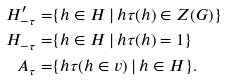Convert formula to latex. <formula><loc_0><loc_0><loc_500><loc_500>H ^ { \prime } _ { - \tau } = & \{ h \in H \, | \, h \tau ( h ) \in Z ( G ) \} \\ H _ { - \tau } = & \{ h \in H \, | \, h \tau ( h ) = 1 \} \\ A _ { \tau } = & \{ h \tau ( h \in v ) \, | \, h \in H \} .</formula> 